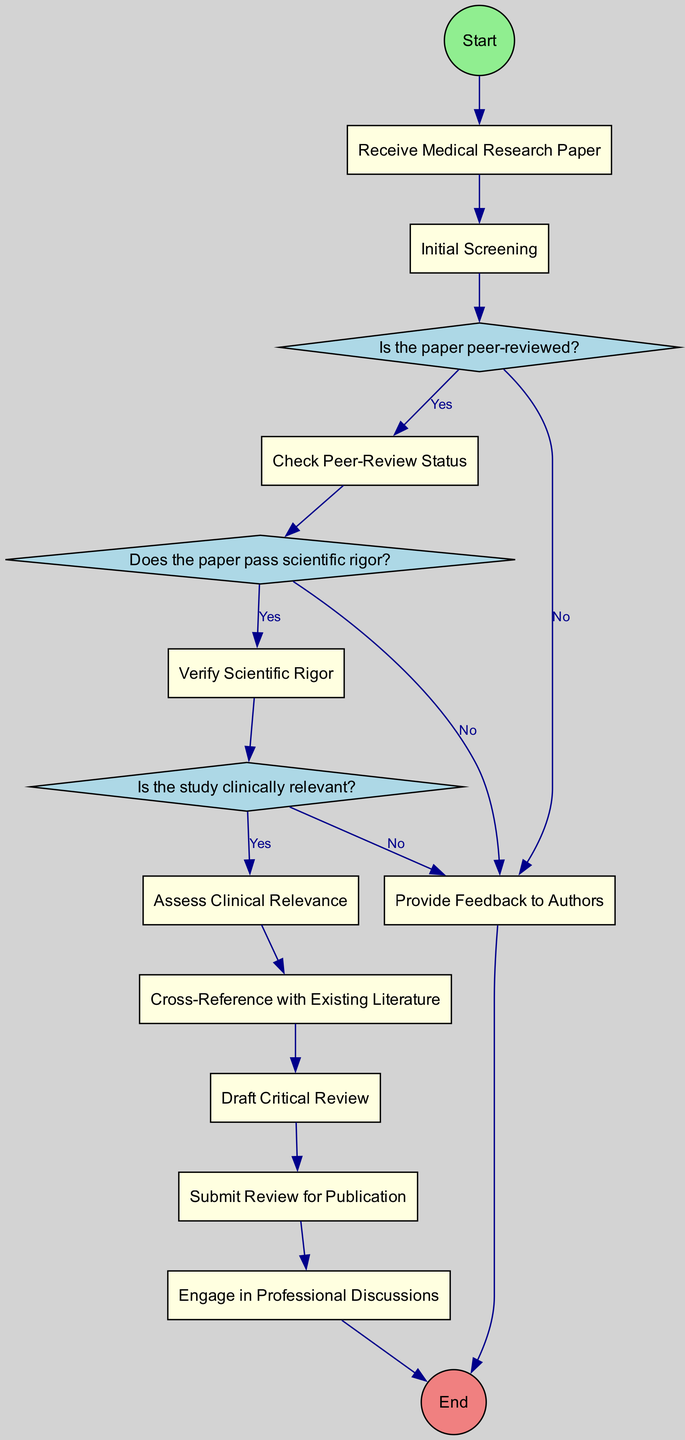What is the first activity in the diagram? The first activity in the diagram is "Receive Medical Research Paper," which is the initial step after starting the workflow.
Answer: Receive Medical Research Paper How many decision points are present in the diagram? The diagram contains three decision points, which are related to the peer-review status, scientific rigor, and clinical relevance of the paper.
Answer: 3 What activity follows the "Initial Screening" in the workflow? After the "Initial Screening," the next activity is "Check Peer-Review Status," which assesses whether the paper was peer-reviewed.
Answer: Check Peer-Review Status What happens if the paper does not pass the scientific rigor evaluation? If the paper does not pass the scientific rigor evaluation, the workflow will move to "Provide Feedback to Authors," indicating that the paper is not scientifically sound.
Answer: Provide Feedback to Authors Which activity precedes the "Draft Critical Review"? The activity that precedes the "Draft Critical Review" is "Cross-Reference with Existing Literature," where the findings are compared with established literature before the review is prepared.
Answer: Cross-Reference with Existing Literature In which activity is the critical review submitted for publication? The critical review is submitted for publication in the "Submit Review for Publication" activity, indicating that the review process has reached completion.
Answer: Submit Review for Publication What is the final step in the workflow? The final step in the workflow is "End," which signifies that all review and response activities have been completed.
Answer: End What action occurs immediately after verifying the scientific rigor? Immediately after verifying the scientific rigor, the workflow checks for clinical relevance by moving to the "Is the study clinically relevant?" decision point.
Answer: Is the study clinically relevant? 